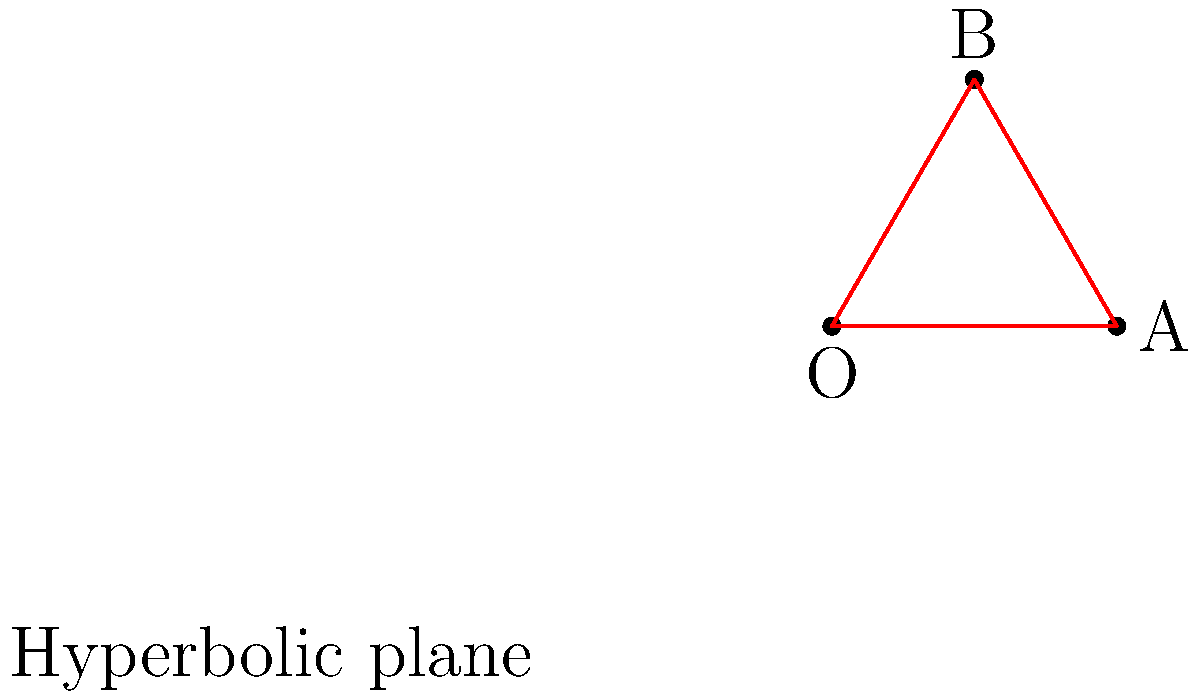In a hyperbolic plane, analogous to curved spacetime, you need to measure the distance between two points A and B. Given that the hyperbolic distance from the origin O to point A is 2 units, and the angle between OA and OB is 60°, what is the hyperbolic distance between points A and B? (Assume the curvature constant $k=-1$) To solve this problem, we'll use the hyperbolic law of cosines:

1) The hyperbolic law of cosines states:
   $\cosh(c) = \cosh(a)\cosh(b) - \sinh(a)\sinh(b)\cos(C)$

   Where $a$, $b$, and $c$ are the lengths of the sides of a hyperbolic triangle, and $C$ is the angle opposite side $c$.

2) We know:
   - $OA = a = 2$
   - Angle $\angle AOB = 60° = \frac{\pi}{3}$
   - We need to find $AB = c$

3) First, we need to find $OB = b$:
   Since the curvature is constant, $OB = OA = 2$

4) Now we can apply the hyperbolic law of cosines:
   $\cosh(c) = \cosh(2)\cosh(2) - \sinh(2)\sinh(2)\cos(\frac{\pi}{3})$

5) Calculate the hyperbolic functions:
   $\cosh(2) \approx 3.7622$ and $\sinh(2) \approx 3.6269$

6) Substitute these values:
   $\cosh(c) = 3.7622 \cdot 3.7622 - 3.6269 \cdot 3.6269 \cdot \cos(\frac{\pi}{3})$
   $\cosh(c) = 14.1541 - 13.1544 \cdot 0.5 = 14.1541 - 6.5772 = 7.5769$

7) To find $c$, we need to apply the inverse hyperbolic cosine function:
   $c = \text{arccosh}(7.5769) \approx 2.7841$

Therefore, the hyperbolic distance between A and B is approximately 2.7841 units.
Answer: $2.7841$ units 